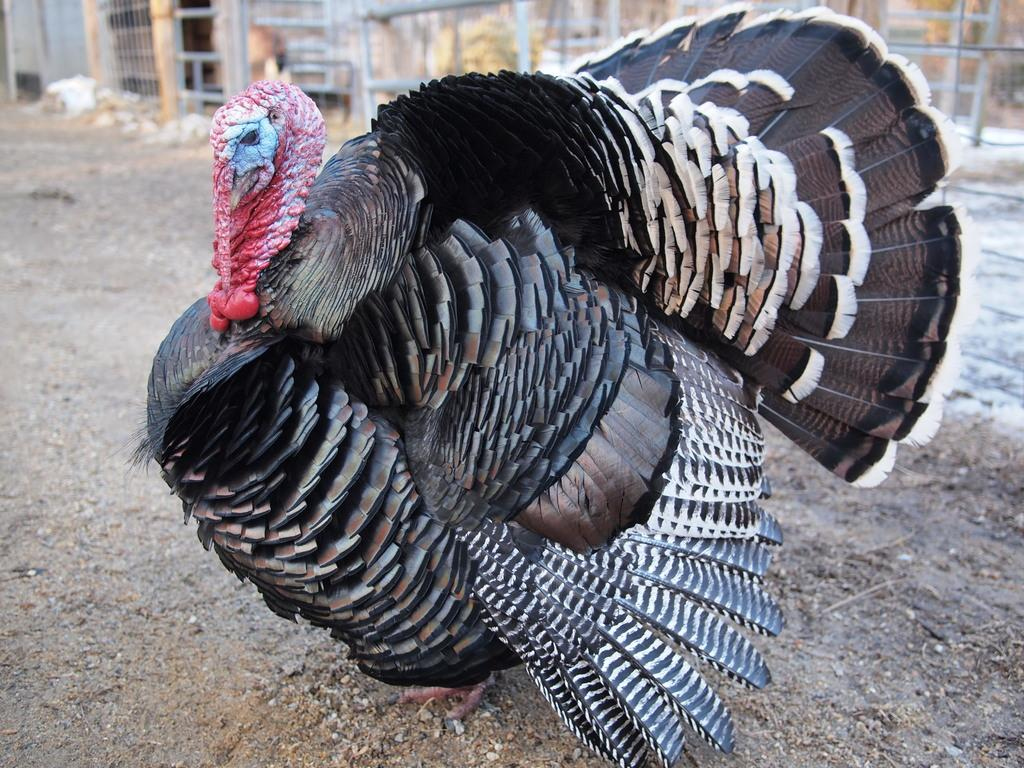What type of animal is in the image? There is a wild turkey in the image. What is visible behind the wild turkey? There is fencing behind the wild turkey in the image. How many pages of the book can be seen in the image? There is no book present in the image, so it is not possible to determine the number of pages. 